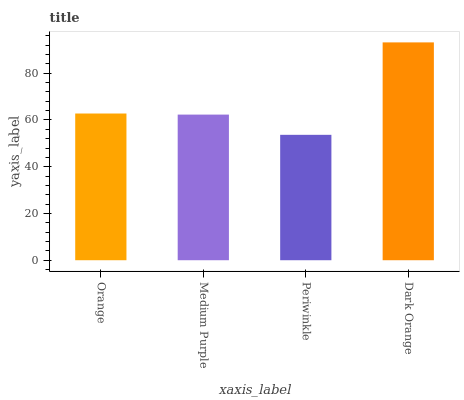Is Medium Purple the minimum?
Answer yes or no. No. Is Medium Purple the maximum?
Answer yes or no. No. Is Orange greater than Medium Purple?
Answer yes or no. Yes. Is Medium Purple less than Orange?
Answer yes or no. Yes. Is Medium Purple greater than Orange?
Answer yes or no. No. Is Orange less than Medium Purple?
Answer yes or no. No. Is Orange the high median?
Answer yes or no. Yes. Is Medium Purple the low median?
Answer yes or no. Yes. Is Medium Purple the high median?
Answer yes or no. No. Is Periwinkle the low median?
Answer yes or no. No. 